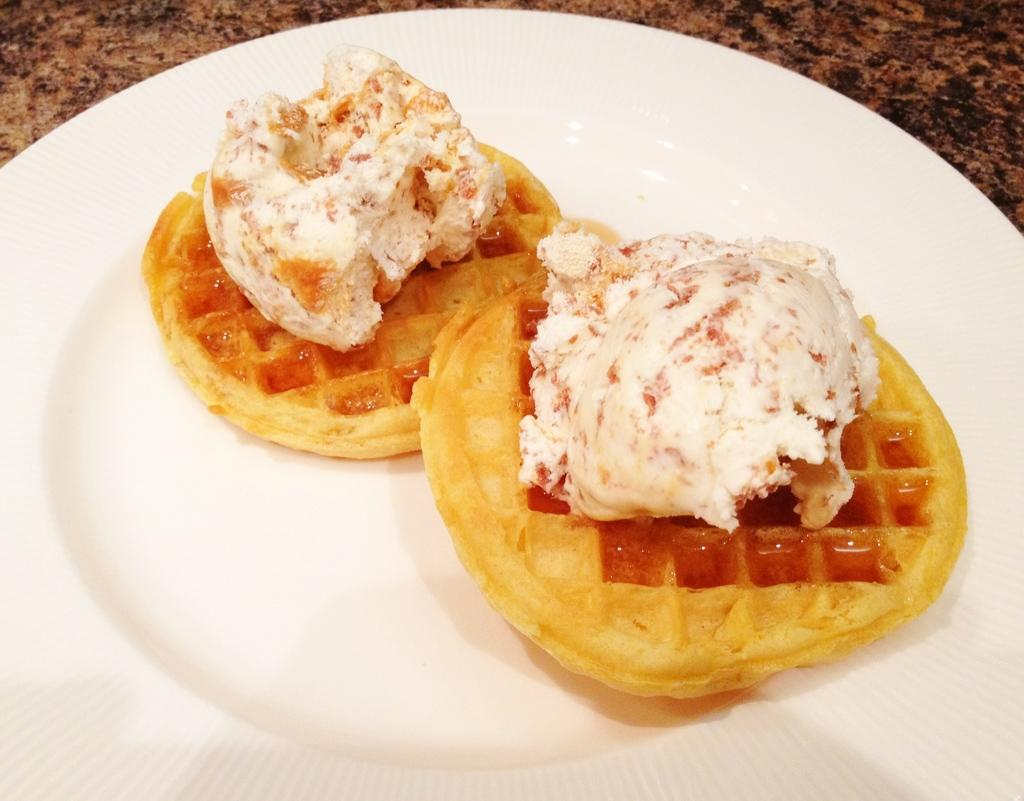What is on the plate that is visible in the image? There is food on the plate in the image. Where is the plate located in the image? The plate is placed on a stone slab. How many basketballs can be seen in the image? There are no basketballs present in the image. What type of fruit is on the plate with the food? The provided facts do not mention any specific type of fruit on the plate, so we cannot determine that from the image. 